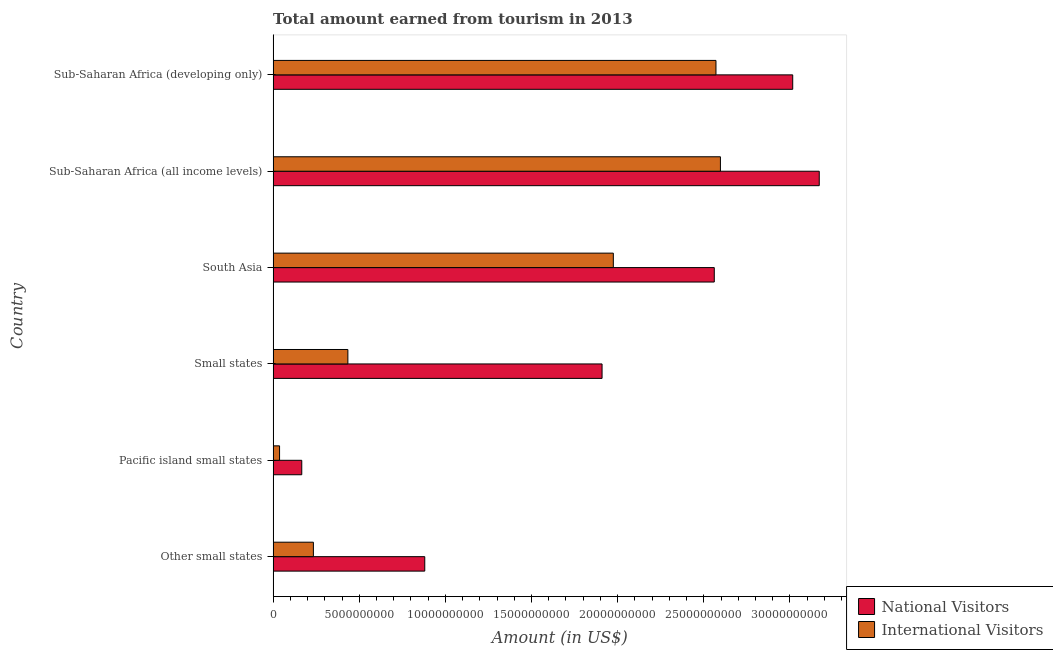How many different coloured bars are there?
Offer a terse response. 2. How many groups of bars are there?
Offer a very short reply. 6. How many bars are there on the 4th tick from the top?
Keep it short and to the point. 2. What is the label of the 5th group of bars from the top?
Make the answer very short. Pacific island small states. What is the amount earned from national visitors in Sub-Saharan Africa (developing only)?
Provide a short and direct response. 3.02e+1. Across all countries, what is the maximum amount earned from national visitors?
Your response must be concise. 3.17e+1. Across all countries, what is the minimum amount earned from national visitors?
Your answer should be very brief. 1.66e+09. In which country was the amount earned from national visitors maximum?
Your answer should be very brief. Sub-Saharan Africa (all income levels). In which country was the amount earned from national visitors minimum?
Your answer should be very brief. Pacific island small states. What is the total amount earned from international visitors in the graph?
Keep it short and to the point. 7.85e+1. What is the difference between the amount earned from national visitors in Other small states and that in South Asia?
Your answer should be compact. -1.68e+1. What is the difference between the amount earned from national visitors in South Asia and the amount earned from international visitors in Small states?
Keep it short and to the point. 2.13e+1. What is the average amount earned from international visitors per country?
Provide a short and direct response. 1.31e+1. What is the difference between the amount earned from national visitors and amount earned from international visitors in Other small states?
Give a very brief answer. 6.47e+09. In how many countries, is the amount earned from national visitors greater than 26000000000 US$?
Provide a succinct answer. 2. What is the ratio of the amount earned from international visitors in Other small states to that in Sub-Saharan Africa (all income levels)?
Offer a terse response. 0.09. What is the difference between the highest and the second highest amount earned from international visitors?
Offer a terse response. 2.58e+08. What is the difference between the highest and the lowest amount earned from international visitors?
Give a very brief answer. 2.56e+1. In how many countries, is the amount earned from national visitors greater than the average amount earned from national visitors taken over all countries?
Offer a very short reply. 3. What does the 2nd bar from the top in Other small states represents?
Keep it short and to the point. National Visitors. What does the 2nd bar from the bottom in South Asia represents?
Offer a terse response. International Visitors. How many bars are there?
Your response must be concise. 12. Are all the bars in the graph horizontal?
Provide a short and direct response. Yes. How many countries are there in the graph?
Offer a terse response. 6. What is the difference between two consecutive major ticks on the X-axis?
Provide a succinct answer. 5.00e+09. Are the values on the major ticks of X-axis written in scientific E-notation?
Make the answer very short. No. How are the legend labels stacked?
Your answer should be very brief. Vertical. What is the title of the graph?
Give a very brief answer. Total amount earned from tourism in 2013. What is the label or title of the X-axis?
Give a very brief answer. Amount (in US$). What is the label or title of the Y-axis?
Offer a terse response. Country. What is the Amount (in US$) of National Visitors in Other small states?
Offer a very short reply. 8.80e+09. What is the Amount (in US$) in International Visitors in Other small states?
Provide a short and direct response. 2.34e+09. What is the Amount (in US$) in National Visitors in Pacific island small states?
Your answer should be compact. 1.66e+09. What is the Amount (in US$) in International Visitors in Pacific island small states?
Ensure brevity in your answer.  3.74e+08. What is the Amount (in US$) in National Visitors in Small states?
Give a very brief answer. 1.91e+1. What is the Amount (in US$) in International Visitors in Small states?
Provide a short and direct response. 4.34e+09. What is the Amount (in US$) in National Visitors in South Asia?
Offer a very short reply. 2.56e+1. What is the Amount (in US$) of International Visitors in South Asia?
Provide a short and direct response. 1.97e+1. What is the Amount (in US$) of National Visitors in Sub-Saharan Africa (all income levels)?
Ensure brevity in your answer.  3.17e+1. What is the Amount (in US$) of International Visitors in Sub-Saharan Africa (all income levels)?
Offer a terse response. 2.60e+1. What is the Amount (in US$) in National Visitors in Sub-Saharan Africa (developing only)?
Keep it short and to the point. 3.02e+1. What is the Amount (in US$) in International Visitors in Sub-Saharan Africa (developing only)?
Offer a terse response. 2.57e+1. Across all countries, what is the maximum Amount (in US$) of National Visitors?
Your response must be concise. 3.17e+1. Across all countries, what is the maximum Amount (in US$) in International Visitors?
Provide a short and direct response. 2.60e+1. Across all countries, what is the minimum Amount (in US$) in National Visitors?
Your answer should be very brief. 1.66e+09. Across all countries, what is the minimum Amount (in US$) in International Visitors?
Provide a short and direct response. 3.74e+08. What is the total Amount (in US$) in National Visitors in the graph?
Your answer should be compact. 1.17e+11. What is the total Amount (in US$) in International Visitors in the graph?
Keep it short and to the point. 7.85e+1. What is the difference between the Amount (in US$) in National Visitors in Other small states and that in Pacific island small states?
Offer a terse response. 7.14e+09. What is the difference between the Amount (in US$) of International Visitors in Other small states and that in Pacific island small states?
Offer a very short reply. 1.96e+09. What is the difference between the Amount (in US$) of National Visitors in Other small states and that in Small states?
Offer a terse response. -1.03e+1. What is the difference between the Amount (in US$) of International Visitors in Other small states and that in Small states?
Provide a succinct answer. -2.00e+09. What is the difference between the Amount (in US$) of National Visitors in Other small states and that in South Asia?
Your answer should be very brief. -1.68e+1. What is the difference between the Amount (in US$) of International Visitors in Other small states and that in South Asia?
Make the answer very short. -1.74e+1. What is the difference between the Amount (in US$) in National Visitors in Other small states and that in Sub-Saharan Africa (all income levels)?
Offer a very short reply. -2.29e+1. What is the difference between the Amount (in US$) in International Visitors in Other small states and that in Sub-Saharan Africa (all income levels)?
Make the answer very short. -2.36e+1. What is the difference between the Amount (in US$) of National Visitors in Other small states and that in Sub-Saharan Africa (developing only)?
Provide a short and direct response. -2.14e+1. What is the difference between the Amount (in US$) of International Visitors in Other small states and that in Sub-Saharan Africa (developing only)?
Give a very brief answer. -2.34e+1. What is the difference between the Amount (in US$) in National Visitors in Pacific island small states and that in Small states?
Your answer should be compact. -1.74e+1. What is the difference between the Amount (in US$) in International Visitors in Pacific island small states and that in Small states?
Offer a very short reply. -3.97e+09. What is the difference between the Amount (in US$) of National Visitors in Pacific island small states and that in South Asia?
Your answer should be very brief. -2.39e+1. What is the difference between the Amount (in US$) of International Visitors in Pacific island small states and that in South Asia?
Ensure brevity in your answer.  -1.94e+1. What is the difference between the Amount (in US$) in National Visitors in Pacific island small states and that in Sub-Saharan Africa (all income levels)?
Offer a terse response. -3.00e+1. What is the difference between the Amount (in US$) of International Visitors in Pacific island small states and that in Sub-Saharan Africa (all income levels)?
Offer a very short reply. -2.56e+1. What is the difference between the Amount (in US$) in National Visitors in Pacific island small states and that in Sub-Saharan Africa (developing only)?
Offer a terse response. -2.85e+1. What is the difference between the Amount (in US$) of International Visitors in Pacific island small states and that in Sub-Saharan Africa (developing only)?
Offer a terse response. -2.53e+1. What is the difference between the Amount (in US$) in National Visitors in Small states and that in South Asia?
Provide a succinct answer. -6.52e+09. What is the difference between the Amount (in US$) in International Visitors in Small states and that in South Asia?
Ensure brevity in your answer.  -1.54e+1. What is the difference between the Amount (in US$) of National Visitors in Small states and that in Sub-Saharan Africa (all income levels)?
Keep it short and to the point. -1.26e+1. What is the difference between the Amount (in US$) in International Visitors in Small states and that in Sub-Saharan Africa (all income levels)?
Your response must be concise. -2.16e+1. What is the difference between the Amount (in US$) of National Visitors in Small states and that in Sub-Saharan Africa (developing only)?
Provide a short and direct response. -1.11e+1. What is the difference between the Amount (in US$) of International Visitors in Small states and that in Sub-Saharan Africa (developing only)?
Your response must be concise. -2.14e+1. What is the difference between the Amount (in US$) of National Visitors in South Asia and that in Sub-Saharan Africa (all income levels)?
Your response must be concise. -6.09e+09. What is the difference between the Amount (in US$) in International Visitors in South Asia and that in Sub-Saharan Africa (all income levels)?
Ensure brevity in your answer.  -6.22e+09. What is the difference between the Amount (in US$) of National Visitors in South Asia and that in Sub-Saharan Africa (developing only)?
Keep it short and to the point. -4.55e+09. What is the difference between the Amount (in US$) of International Visitors in South Asia and that in Sub-Saharan Africa (developing only)?
Give a very brief answer. -5.96e+09. What is the difference between the Amount (in US$) of National Visitors in Sub-Saharan Africa (all income levels) and that in Sub-Saharan Africa (developing only)?
Give a very brief answer. 1.54e+09. What is the difference between the Amount (in US$) of International Visitors in Sub-Saharan Africa (all income levels) and that in Sub-Saharan Africa (developing only)?
Provide a short and direct response. 2.58e+08. What is the difference between the Amount (in US$) in National Visitors in Other small states and the Amount (in US$) in International Visitors in Pacific island small states?
Make the answer very short. 8.43e+09. What is the difference between the Amount (in US$) in National Visitors in Other small states and the Amount (in US$) in International Visitors in Small states?
Keep it short and to the point. 4.46e+09. What is the difference between the Amount (in US$) of National Visitors in Other small states and the Amount (in US$) of International Visitors in South Asia?
Offer a very short reply. -1.09e+1. What is the difference between the Amount (in US$) of National Visitors in Other small states and the Amount (in US$) of International Visitors in Sub-Saharan Africa (all income levels)?
Provide a succinct answer. -1.72e+1. What is the difference between the Amount (in US$) of National Visitors in Other small states and the Amount (in US$) of International Visitors in Sub-Saharan Africa (developing only)?
Offer a very short reply. -1.69e+1. What is the difference between the Amount (in US$) in National Visitors in Pacific island small states and the Amount (in US$) in International Visitors in Small states?
Your answer should be compact. -2.68e+09. What is the difference between the Amount (in US$) of National Visitors in Pacific island small states and the Amount (in US$) of International Visitors in South Asia?
Provide a succinct answer. -1.81e+1. What is the difference between the Amount (in US$) in National Visitors in Pacific island small states and the Amount (in US$) in International Visitors in Sub-Saharan Africa (all income levels)?
Keep it short and to the point. -2.43e+1. What is the difference between the Amount (in US$) in National Visitors in Pacific island small states and the Amount (in US$) in International Visitors in Sub-Saharan Africa (developing only)?
Your response must be concise. -2.40e+1. What is the difference between the Amount (in US$) of National Visitors in Small states and the Amount (in US$) of International Visitors in South Asia?
Your response must be concise. -6.54e+08. What is the difference between the Amount (in US$) in National Visitors in Small states and the Amount (in US$) in International Visitors in Sub-Saharan Africa (all income levels)?
Offer a terse response. -6.87e+09. What is the difference between the Amount (in US$) in National Visitors in Small states and the Amount (in US$) in International Visitors in Sub-Saharan Africa (developing only)?
Provide a succinct answer. -6.61e+09. What is the difference between the Amount (in US$) in National Visitors in South Asia and the Amount (in US$) in International Visitors in Sub-Saharan Africa (all income levels)?
Your answer should be compact. -3.56e+08. What is the difference between the Amount (in US$) of National Visitors in South Asia and the Amount (in US$) of International Visitors in Sub-Saharan Africa (developing only)?
Keep it short and to the point. -9.78e+07. What is the difference between the Amount (in US$) of National Visitors in Sub-Saharan Africa (all income levels) and the Amount (in US$) of International Visitors in Sub-Saharan Africa (developing only)?
Your answer should be compact. 6.00e+09. What is the average Amount (in US$) in National Visitors per country?
Your answer should be compact. 1.95e+1. What is the average Amount (in US$) of International Visitors per country?
Ensure brevity in your answer.  1.31e+1. What is the difference between the Amount (in US$) in National Visitors and Amount (in US$) in International Visitors in Other small states?
Provide a succinct answer. 6.47e+09. What is the difference between the Amount (in US$) of National Visitors and Amount (in US$) of International Visitors in Pacific island small states?
Ensure brevity in your answer.  1.29e+09. What is the difference between the Amount (in US$) of National Visitors and Amount (in US$) of International Visitors in Small states?
Offer a terse response. 1.48e+1. What is the difference between the Amount (in US$) of National Visitors and Amount (in US$) of International Visitors in South Asia?
Give a very brief answer. 5.86e+09. What is the difference between the Amount (in US$) in National Visitors and Amount (in US$) in International Visitors in Sub-Saharan Africa (all income levels)?
Your answer should be very brief. 5.74e+09. What is the difference between the Amount (in US$) of National Visitors and Amount (in US$) of International Visitors in Sub-Saharan Africa (developing only)?
Provide a succinct answer. 4.46e+09. What is the ratio of the Amount (in US$) of National Visitors in Other small states to that in Pacific island small states?
Give a very brief answer. 5.3. What is the ratio of the Amount (in US$) of International Visitors in Other small states to that in Pacific island small states?
Give a very brief answer. 6.25. What is the ratio of the Amount (in US$) in National Visitors in Other small states to that in Small states?
Ensure brevity in your answer.  0.46. What is the ratio of the Amount (in US$) in International Visitors in Other small states to that in Small states?
Offer a very short reply. 0.54. What is the ratio of the Amount (in US$) in National Visitors in Other small states to that in South Asia?
Offer a very short reply. 0.34. What is the ratio of the Amount (in US$) of International Visitors in Other small states to that in South Asia?
Keep it short and to the point. 0.12. What is the ratio of the Amount (in US$) of National Visitors in Other small states to that in Sub-Saharan Africa (all income levels)?
Make the answer very short. 0.28. What is the ratio of the Amount (in US$) of International Visitors in Other small states to that in Sub-Saharan Africa (all income levels)?
Your response must be concise. 0.09. What is the ratio of the Amount (in US$) of National Visitors in Other small states to that in Sub-Saharan Africa (developing only)?
Offer a terse response. 0.29. What is the ratio of the Amount (in US$) in International Visitors in Other small states to that in Sub-Saharan Africa (developing only)?
Provide a short and direct response. 0.09. What is the ratio of the Amount (in US$) in National Visitors in Pacific island small states to that in Small states?
Give a very brief answer. 0.09. What is the ratio of the Amount (in US$) of International Visitors in Pacific island small states to that in Small states?
Keep it short and to the point. 0.09. What is the ratio of the Amount (in US$) in National Visitors in Pacific island small states to that in South Asia?
Provide a succinct answer. 0.06. What is the ratio of the Amount (in US$) in International Visitors in Pacific island small states to that in South Asia?
Your answer should be compact. 0.02. What is the ratio of the Amount (in US$) in National Visitors in Pacific island small states to that in Sub-Saharan Africa (all income levels)?
Your answer should be compact. 0.05. What is the ratio of the Amount (in US$) in International Visitors in Pacific island small states to that in Sub-Saharan Africa (all income levels)?
Your answer should be very brief. 0.01. What is the ratio of the Amount (in US$) of National Visitors in Pacific island small states to that in Sub-Saharan Africa (developing only)?
Make the answer very short. 0.06. What is the ratio of the Amount (in US$) of International Visitors in Pacific island small states to that in Sub-Saharan Africa (developing only)?
Ensure brevity in your answer.  0.01. What is the ratio of the Amount (in US$) in National Visitors in Small states to that in South Asia?
Your response must be concise. 0.75. What is the ratio of the Amount (in US$) in International Visitors in Small states to that in South Asia?
Provide a succinct answer. 0.22. What is the ratio of the Amount (in US$) of National Visitors in Small states to that in Sub-Saharan Africa (all income levels)?
Provide a succinct answer. 0.6. What is the ratio of the Amount (in US$) in International Visitors in Small states to that in Sub-Saharan Africa (all income levels)?
Your answer should be very brief. 0.17. What is the ratio of the Amount (in US$) in National Visitors in Small states to that in Sub-Saharan Africa (developing only)?
Offer a very short reply. 0.63. What is the ratio of the Amount (in US$) in International Visitors in Small states to that in Sub-Saharan Africa (developing only)?
Ensure brevity in your answer.  0.17. What is the ratio of the Amount (in US$) of National Visitors in South Asia to that in Sub-Saharan Africa (all income levels)?
Ensure brevity in your answer.  0.81. What is the ratio of the Amount (in US$) in International Visitors in South Asia to that in Sub-Saharan Africa (all income levels)?
Provide a short and direct response. 0.76. What is the ratio of the Amount (in US$) in National Visitors in South Asia to that in Sub-Saharan Africa (developing only)?
Provide a short and direct response. 0.85. What is the ratio of the Amount (in US$) of International Visitors in South Asia to that in Sub-Saharan Africa (developing only)?
Ensure brevity in your answer.  0.77. What is the ratio of the Amount (in US$) in National Visitors in Sub-Saharan Africa (all income levels) to that in Sub-Saharan Africa (developing only)?
Your answer should be compact. 1.05. What is the difference between the highest and the second highest Amount (in US$) in National Visitors?
Ensure brevity in your answer.  1.54e+09. What is the difference between the highest and the second highest Amount (in US$) in International Visitors?
Ensure brevity in your answer.  2.58e+08. What is the difference between the highest and the lowest Amount (in US$) of National Visitors?
Offer a very short reply. 3.00e+1. What is the difference between the highest and the lowest Amount (in US$) in International Visitors?
Keep it short and to the point. 2.56e+1. 